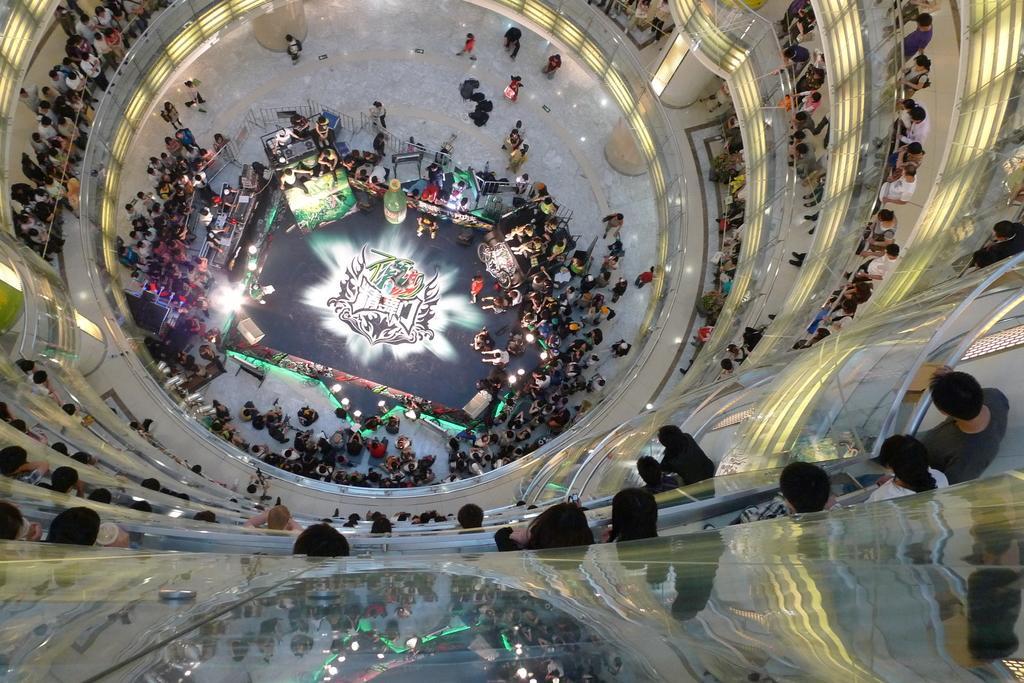Describe this image in one or two sentences. This image is taken from the top of a building where we can see people standing near railing in each and every floor. In the background, there are people standing around a stage, where we can see lights, few devices and posters. 